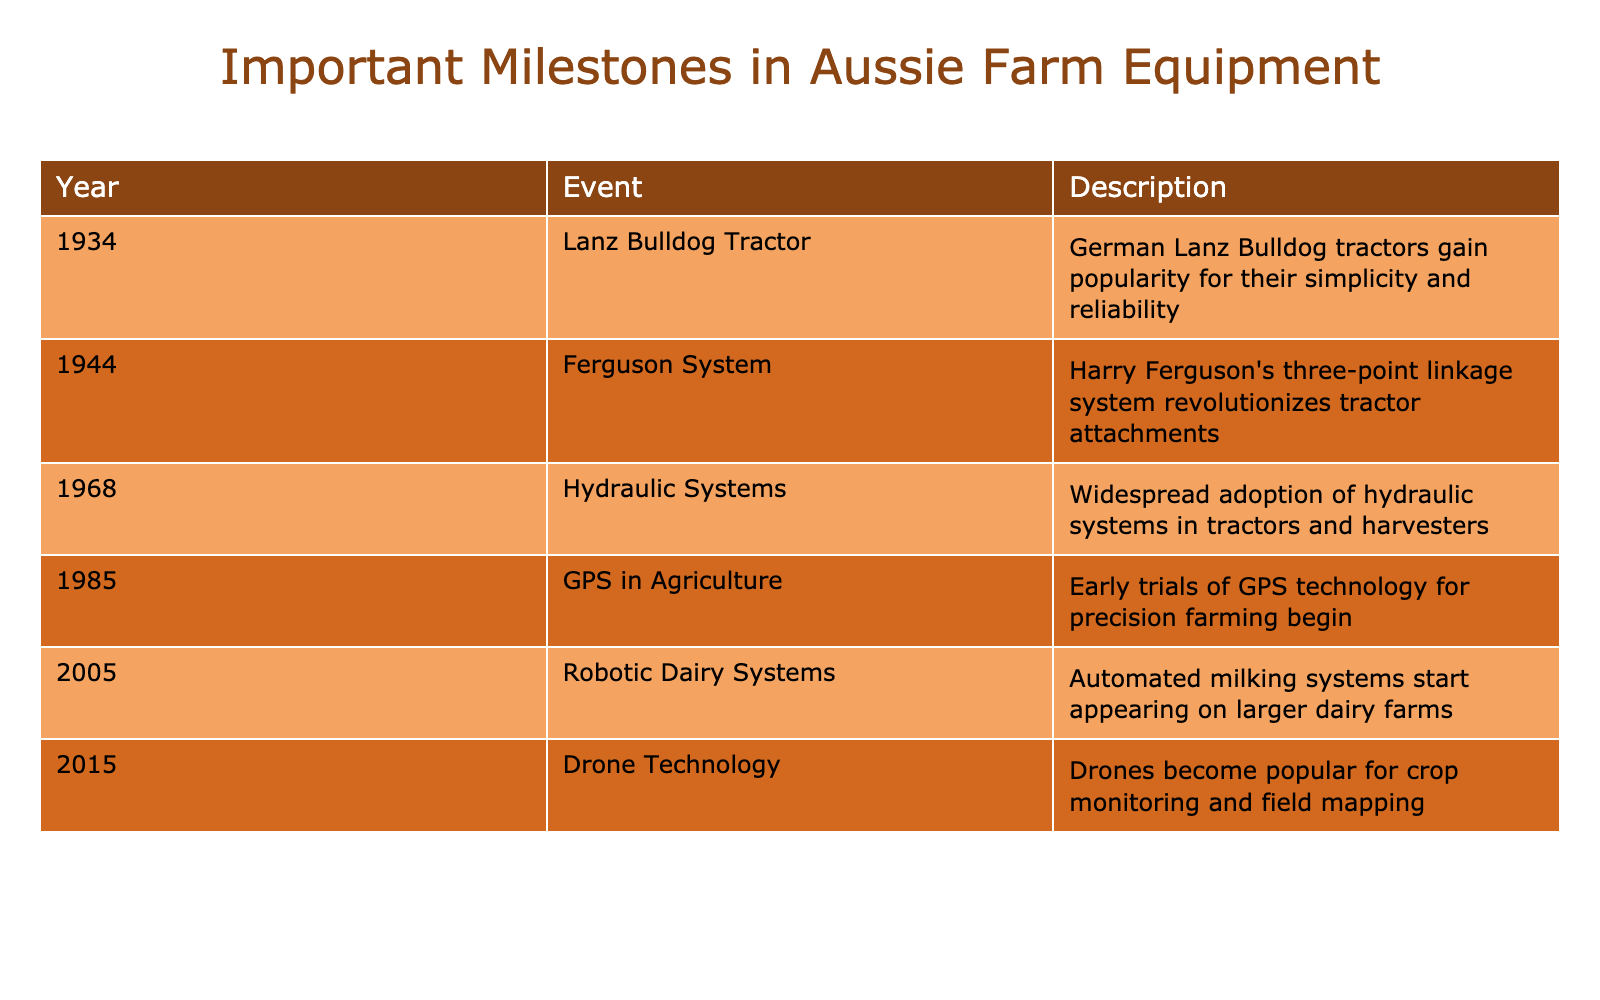What year did the Lanz Bulldog Tractor become popular? The table shows that the Lanz Bulldog Tractor gained popularity in the year 1934.
Answer: 1934 What technological advancement happened in 1944? The table indicates that in 1944, Harry Ferguson introduced the Ferguson System, which revolutionized tractor attachments.
Answer: Ferguson System How many years passed between the adoption of hydraulic systems and the introduction of GPS technology in agriculture? Hydraulic systems were adopted in 1968 and GPS technology began trials in 1985. The difference in years is 1985 - 1968 = 17 years.
Answer: 17 years Was the introduction of automated milking systems before or after 2000? According to the table, robotic dairy systems were introduced in 2005, which is after the year 2000.
Answer: After Which two events related to farming technology happened in the 2000s? The table indicates that both robotic dairy systems in 2005 and drone technology in 2015 are part of the 2000s advancements in farming technology.
Answer: Robotic Dairy Systems and Drone Technology What is the difference in years between the introduction of drones and the Lanz Bulldog Tractor? Drones became popular in 2015 and the Lanz Bulldog Tractor gained popularity in 1934. The difference is calculated as 2015 - 1934 = 81 years.
Answer: 81 years Was the Ferguson System introduced after the widespread adoption of hydraulic systems? The table shows that the Ferguson System was introduced in 1944 and hydraulic systems were adopted in 1968, meaning Ferguson System came before the widespread adoption of hydraulic systems.
Answer: No Identify the earliest event listed related to Australian farm equipment development. The earliest event in the table is the Lanz Bulldog Tractor gaining popularity in 1934, which is the only one listed before 1944.
Answer: Lanz Bulldog Tractor in 1934 How many significant developments in farm equipment occurred between 2000 and 2015? The table indicates two significant developments: robotic dairy systems in 2005 and drone technology in 2015, which fall within the year range mentioned.
Answer: 2 developments 